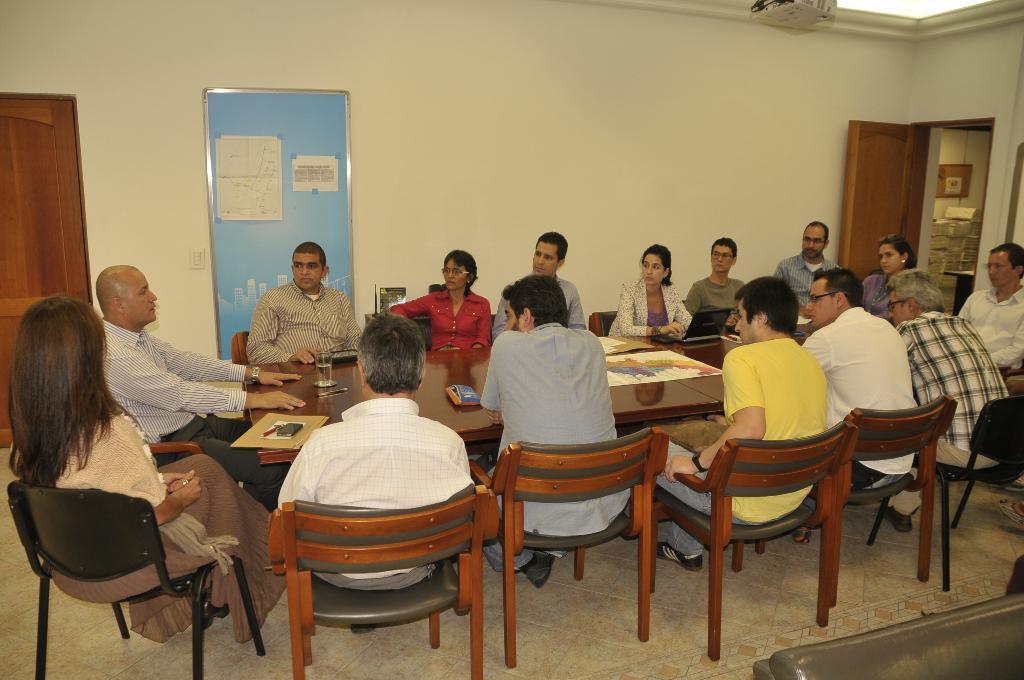In one or two sentences, can you explain what this image depicts? This picture is taken in a room, There is a table which is in black color on that table there is a glass, There is a book, There are some people sitting on the chairs which are in yellow color around the table, In the background there is a blue color board and white color wall, In the left side there is a brown color door, In the right side there is a brown color door open. 